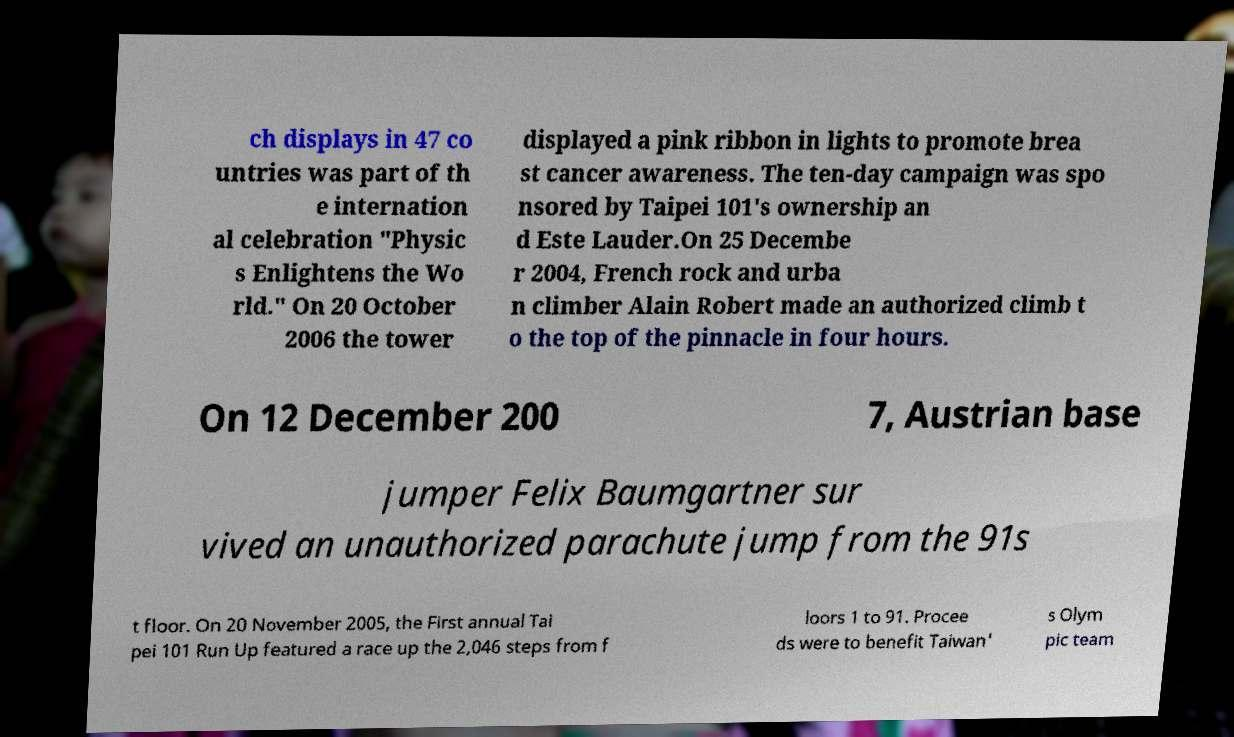Could you extract and type out the text from this image? ch displays in 47 co untries was part of th e internation al celebration "Physic s Enlightens the Wo rld." On 20 October 2006 the tower displayed a pink ribbon in lights to promote brea st cancer awareness. The ten-day campaign was spo nsored by Taipei 101's ownership an d Este Lauder.On 25 Decembe r 2004, French rock and urba n climber Alain Robert made an authorized climb t o the top of the pinnacle in four hours. On 12 December 200 7, Austrian base jumper Felix Baumgartner sur vived an unauthorized parachute jump from the 91s t floor. On 20 November 2005, the First annual Tai pei 101 Run Up featured a race up the 2,046 steps from f loors 1 to 91. Procee ds were to benefit Taiwan' s Olym pic team 